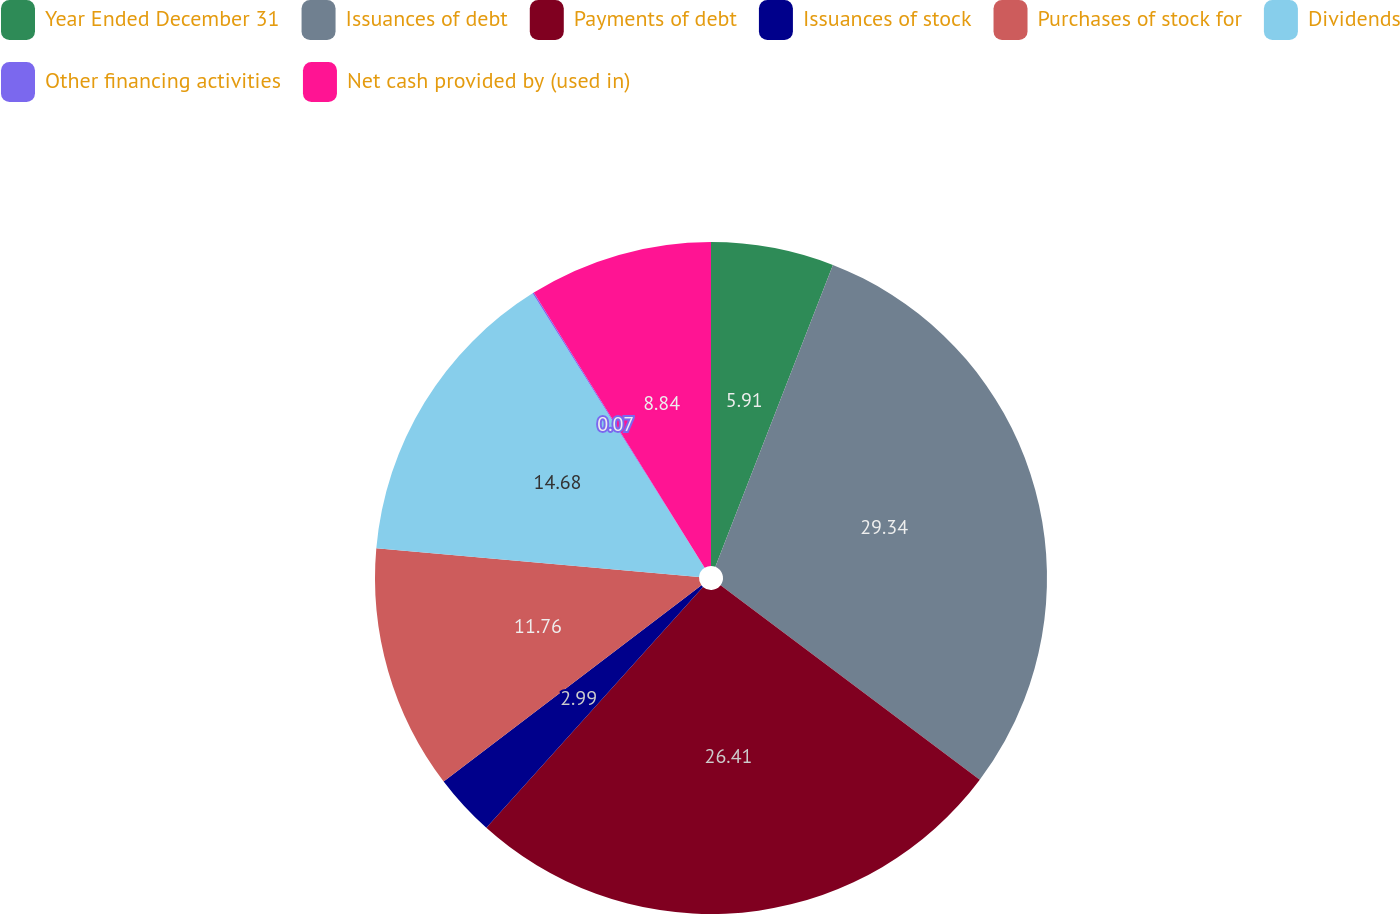Convert chart. <chart><loc_0><loc_0><loc_500><loc_500><pie_chart><fcel>Year Ended December 31<fcel>Issuances of debt<fcel>Payments of debt<fcel>Issuances of stock<fcel>Purchases of stock for<fcel>Dividends<fcel>Other financing activities<fcel>Net cash provided by (used in)<nl><fcel>5.91%<fcel>29.33%<fcel>26.41%<fcel>2.99%<fcel>11.76%<fcel>14.68%<fcel>0.07%<fcel>8.84%<nl></chart> 